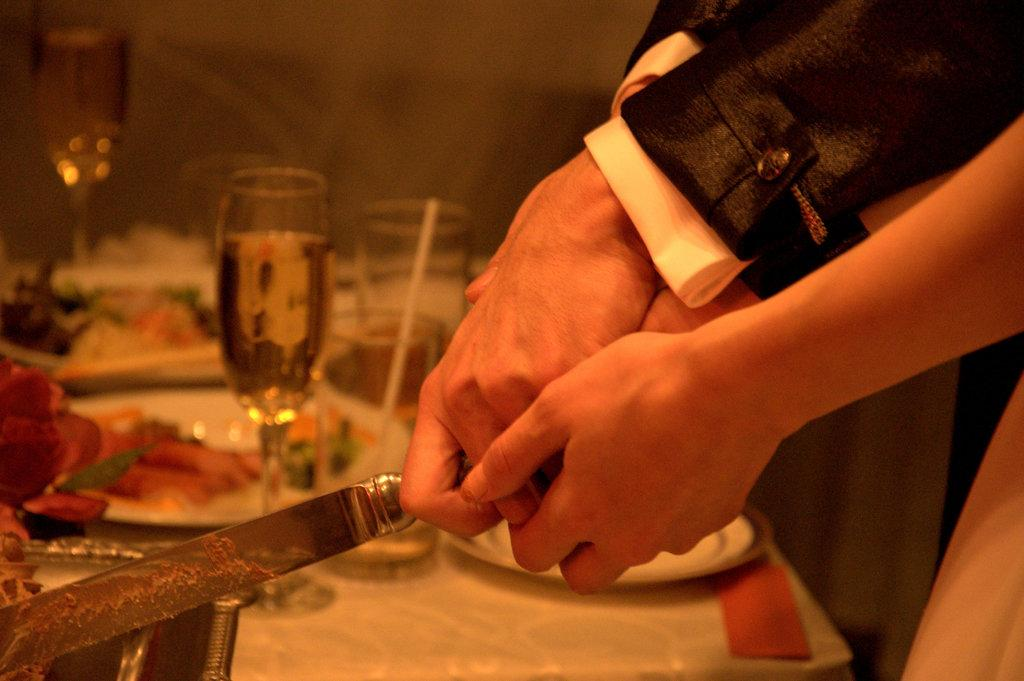How many people are the two persons are interacting in the image? The two persons are holding hands in the image. What else are the two persons holding in the image? The two persons are also holding a knife. What can be seen on the table in the image? There are glasses and food on a white-colored table in the image. What type of men can be seen teaching in the image? There is no reference to men or teaching in the image; it features two persons holding hands and a knife. What kind of thread is being used to sew the food in the image? There is no thread or sewing activity present in the image; it shows food on a table with glasses and two persons holding hands and a knife. 